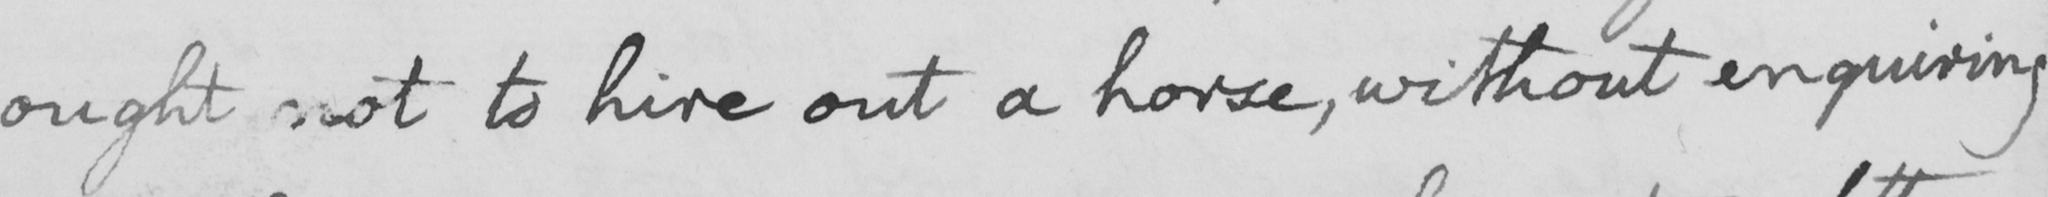What text is written in this handwritten line? ought not to hire out a horse , without enquiring 